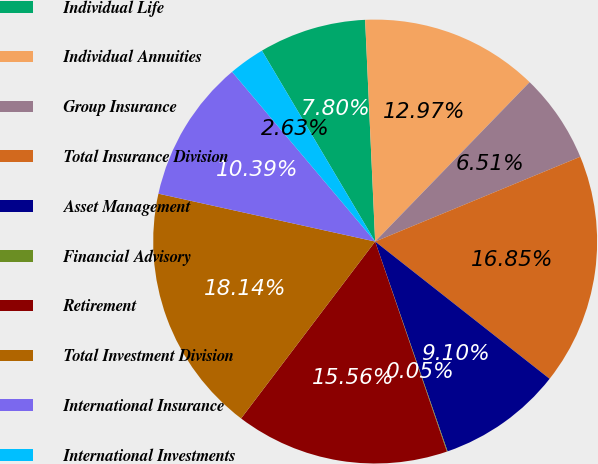<chart> <loc_0><loc_0><loc_500><loc_500><pie_chart><fcel>Individual Life<fcel>Individual Annuities<fcel>Group Insurance<fcel>Total Insurance Division<fcel>Asset Management<fcel>Financial Advisory<fcel>Retirement<fcel>Total Investment Division<fcel>International Insurance<fcel>International Investments<nl><fcel>7.8%<fcel>12.97%<fcel>6.51%<fcel>16.85%<fcel>9.1%<fcel>0.05%<fcel>15.56%<fcel>18.14%<fcel>10.39%<fcel>2.63%<nl></chart> 